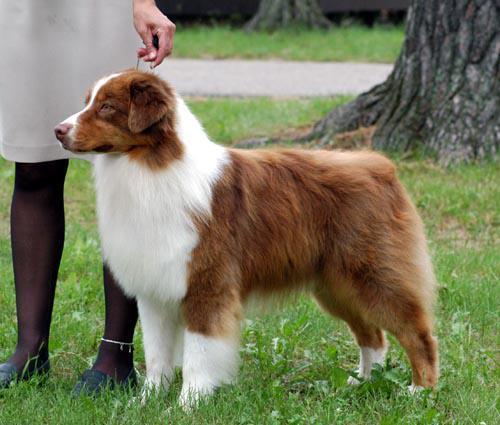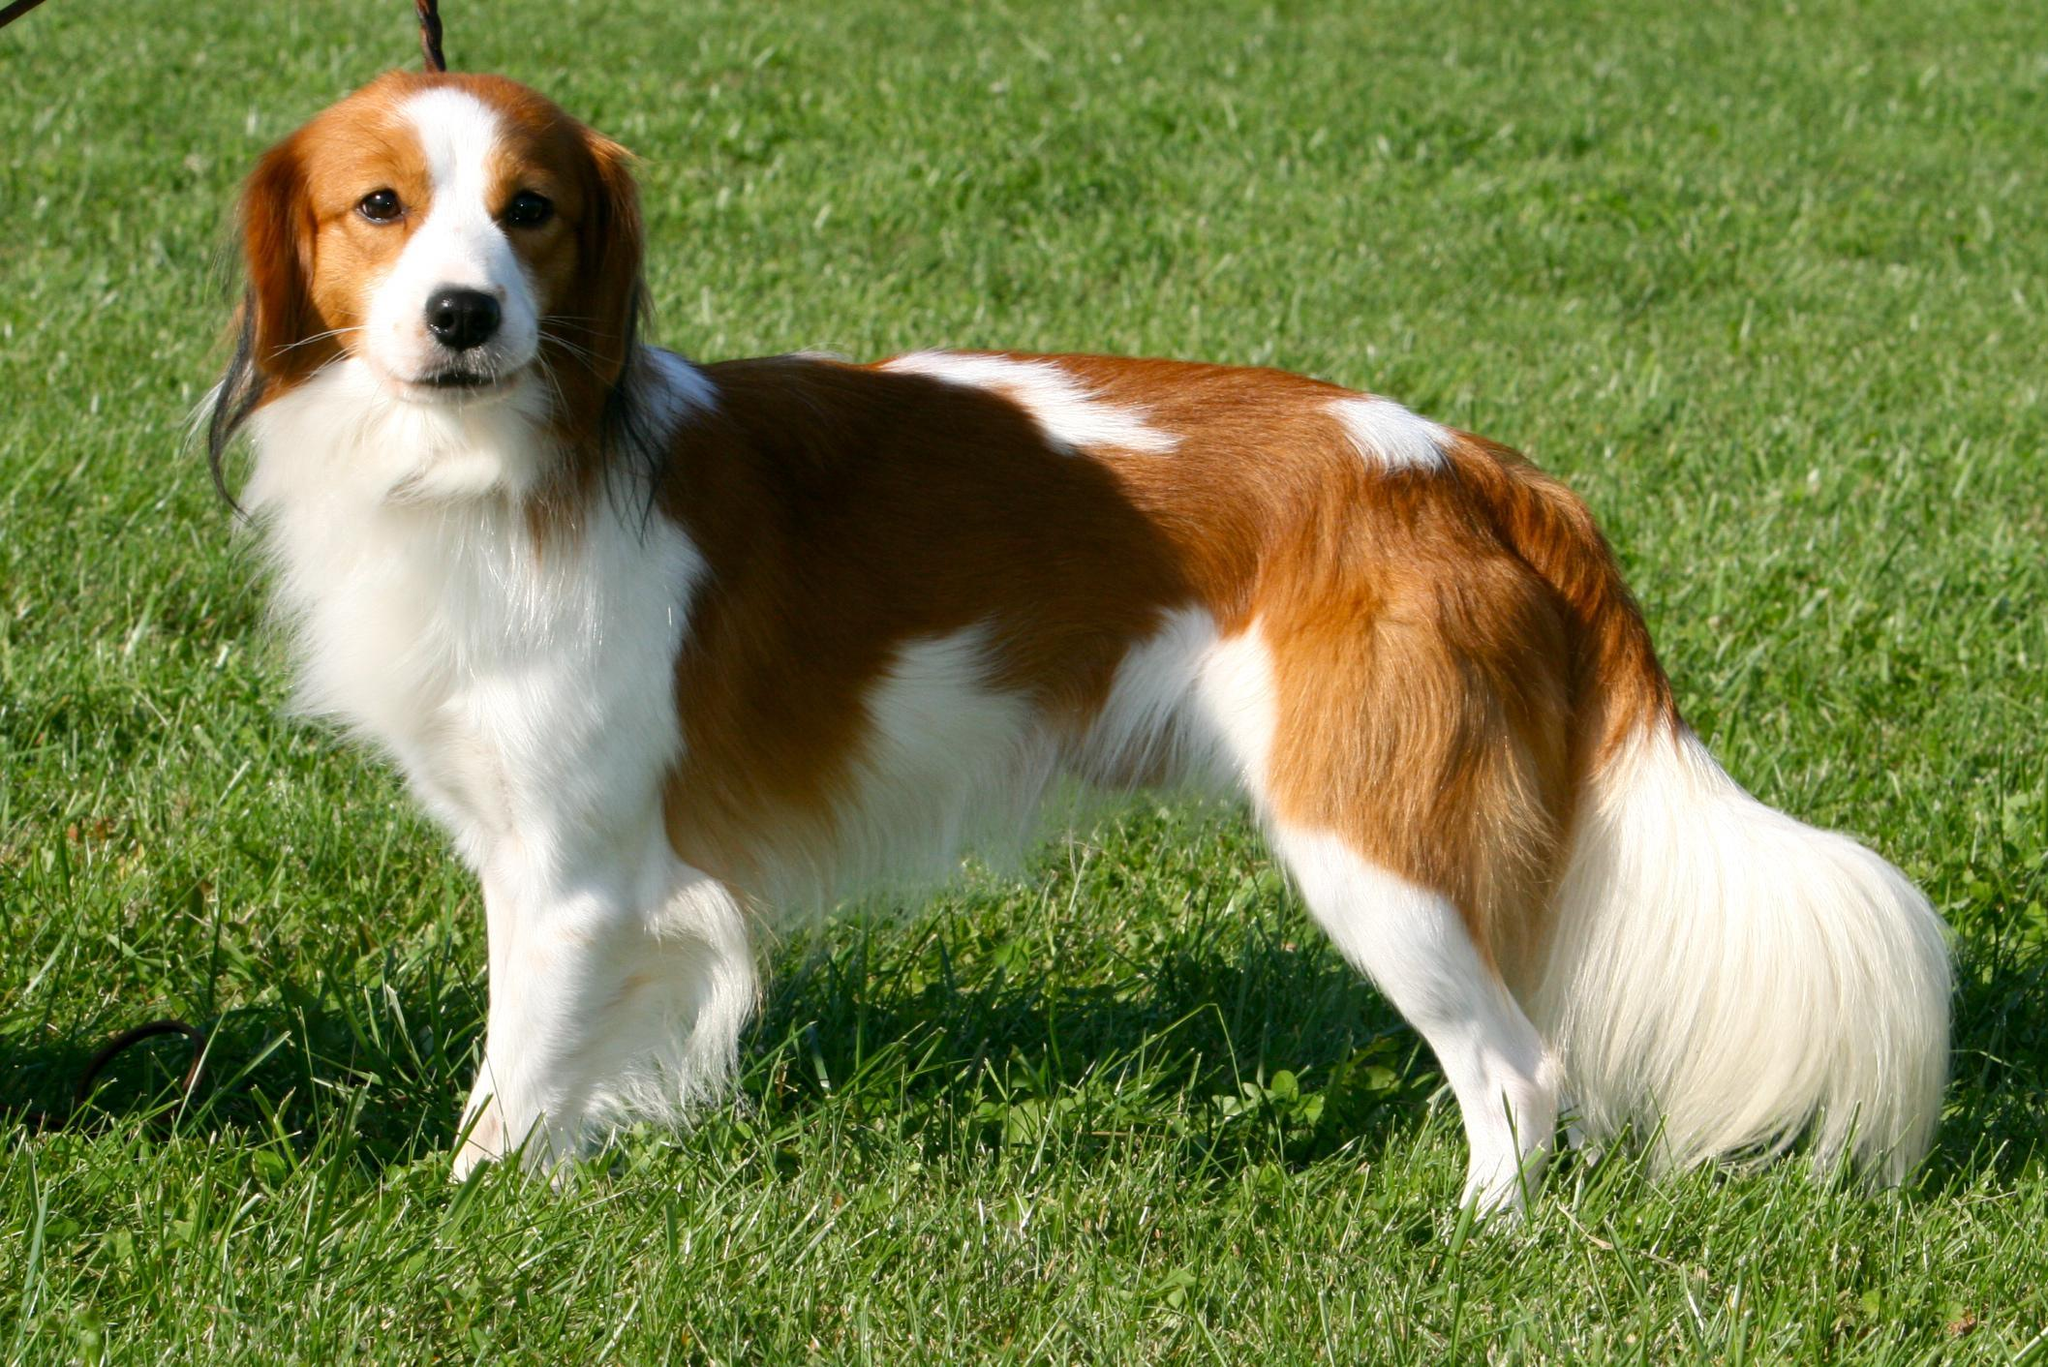The first image is the image on the left, the second image is the image on the right. Considering the images on both sides, is "At least one dog has its mouth open." valid? Answer yes or no. No. The first image is the image on the left, the second image is the image on the right. Given the left and right images, does the statement "One dog is black with white on its legs and chest." hold true? Answer yes or no. No. 